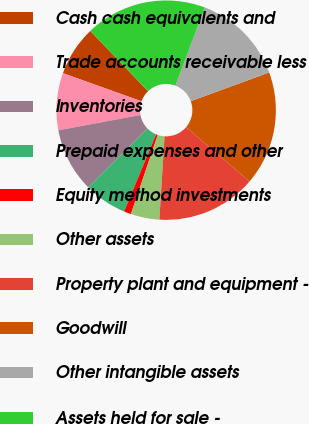Convert chart. <chart><loc_0><loc_0><loc_500><loc_500><pie_chart><fcel>Cash cash equivalents and<fcel>Trade accounts receivable less<fcel>Inventories<fcel>Prepaid expenses and other<fcel>Equity method investments<fcel>Other assets<fcel>Property plant and equipment -<fcel>Goodwill<fcel>Other intangible assets<fcel>Assets held for sale -<nl><fcel>7.37%<fcel>8.42%<fcel>9.47%<fcel>6.32%<fcel>1.06%<fcel>4.22%<fcel>14.73%<fcel>16.84%<fcel>13.68%<fcel>17.89%<nl></chart> 